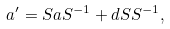Convert formula to latex. <formula><loc_0><loc_0><loc_500><loc_500>a ^ { \prime } = S a S ^ { - 1 } + d S S ^ { - 1 } ,</formula> 